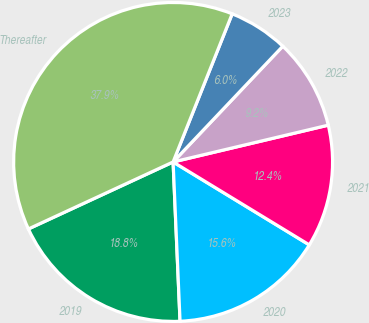Convert chart to OTSL. <chart><loc_0><loc_0><loc_500><loc_500><pie_chart><fcel>2019<fcel>2020<fcel>2021<fcel>2022<fcel>2023<fcel>Thereafter<nl><fcel>18.79%<fcel>15.6%<fcel>12.41%<fcel>9.22%<fcel>6.03%<fcel>37.94%<nl></chart> 